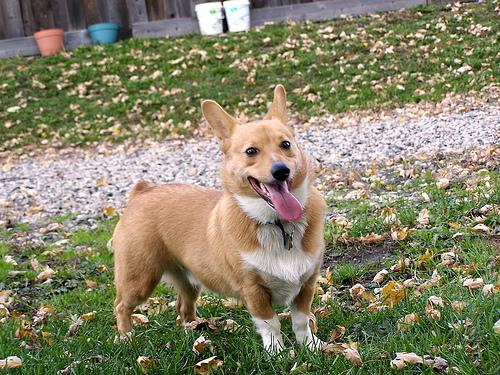Identify the breed of the dog in the image. The delightful canine featured in the photograph is a Pembroke Welsh Corgi, distinguished by its charming short stature, sturdy frame, and perky ears poised in alertness. A beloved breed celebrated for its affable nature and keen intelligence, it wears a coat that is a plush tapestry of tan and white—the hallmark hues of its kind. This breed’s origins are steeped in the pastoral landscapes of Wales, where they were once revered as tireless herding dogs. Observing its bright, eager eyes and sprightly demeanor, it's easy to imagine how it might enliven any home with its playful spirit and loyal companionship. 